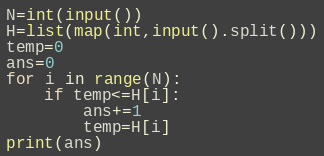Convert code to text. <code><loc_0><loc_0><loc_500><loc_500><_Python_>N=int(input())
H=list(map(int,input().split()))
temp=0
ans=0
for i in range(N):
    if temp<=H[i]:
        ans+=1
        temp=H[i]
print(ans)
</code> 